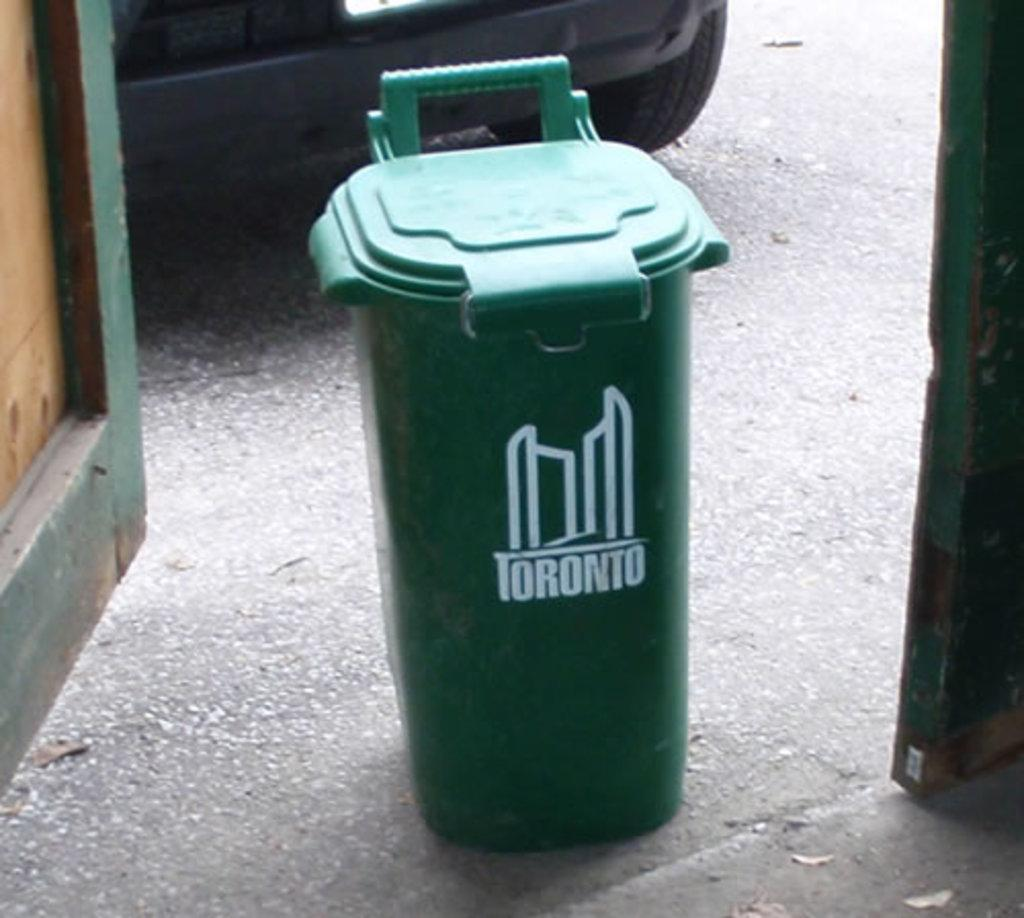<image>
Create a compact narrative representing the image presented. a green Toronto trash can outside on the pavement. 